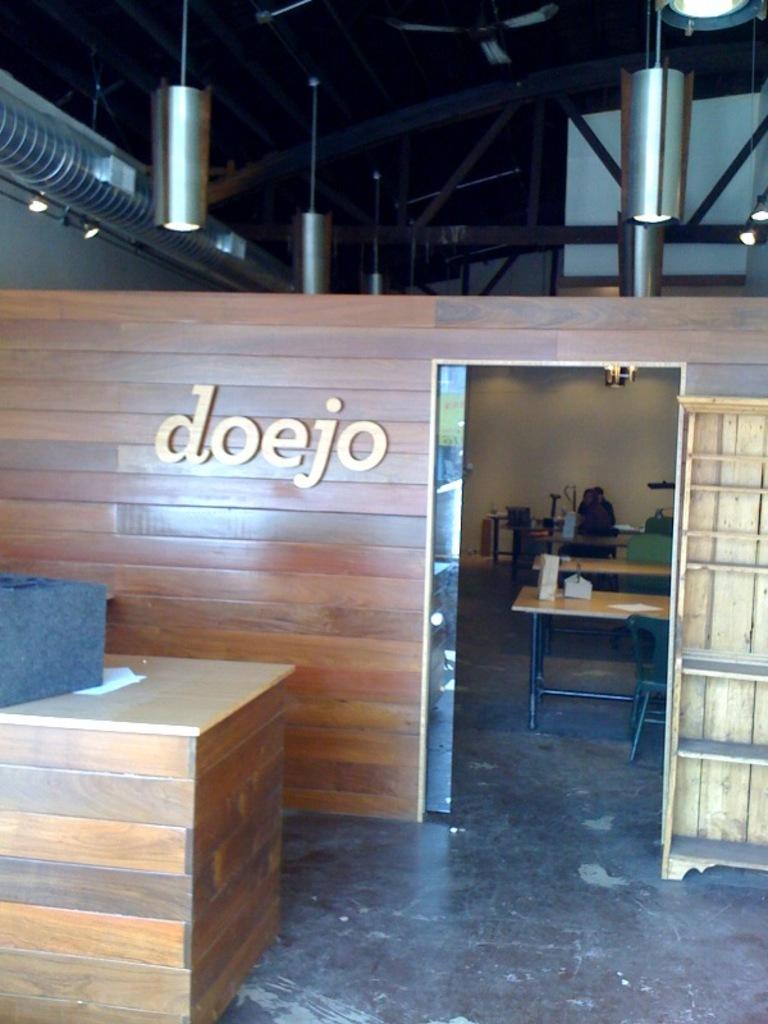What business is this?
Your answer should be compact. Doejo. 